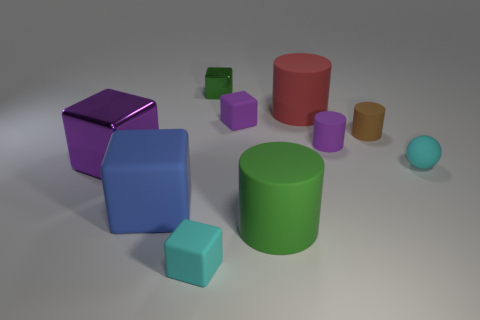Subtract all tiny cyan blocks. How many blocks are left? 4 Subtract all green blocks. How many blocks are left? 4 Subtract all yellow blocks. Subtract all gray cylinders. How many blocks are left? 5 Subtract all cylinders. How many objects are left? 6 Subtract all tiny cyan balls. Subtract all purple rubber cylinders. How many objects are left? 8 Add 8 brown matte cylinders. How many brown matte cylinders are left? 9 Add 3 big gray shiny spheres. How many big gray shiny spheres exist? 3 Subtract 1 red cylinders. How many objects are left? 9 